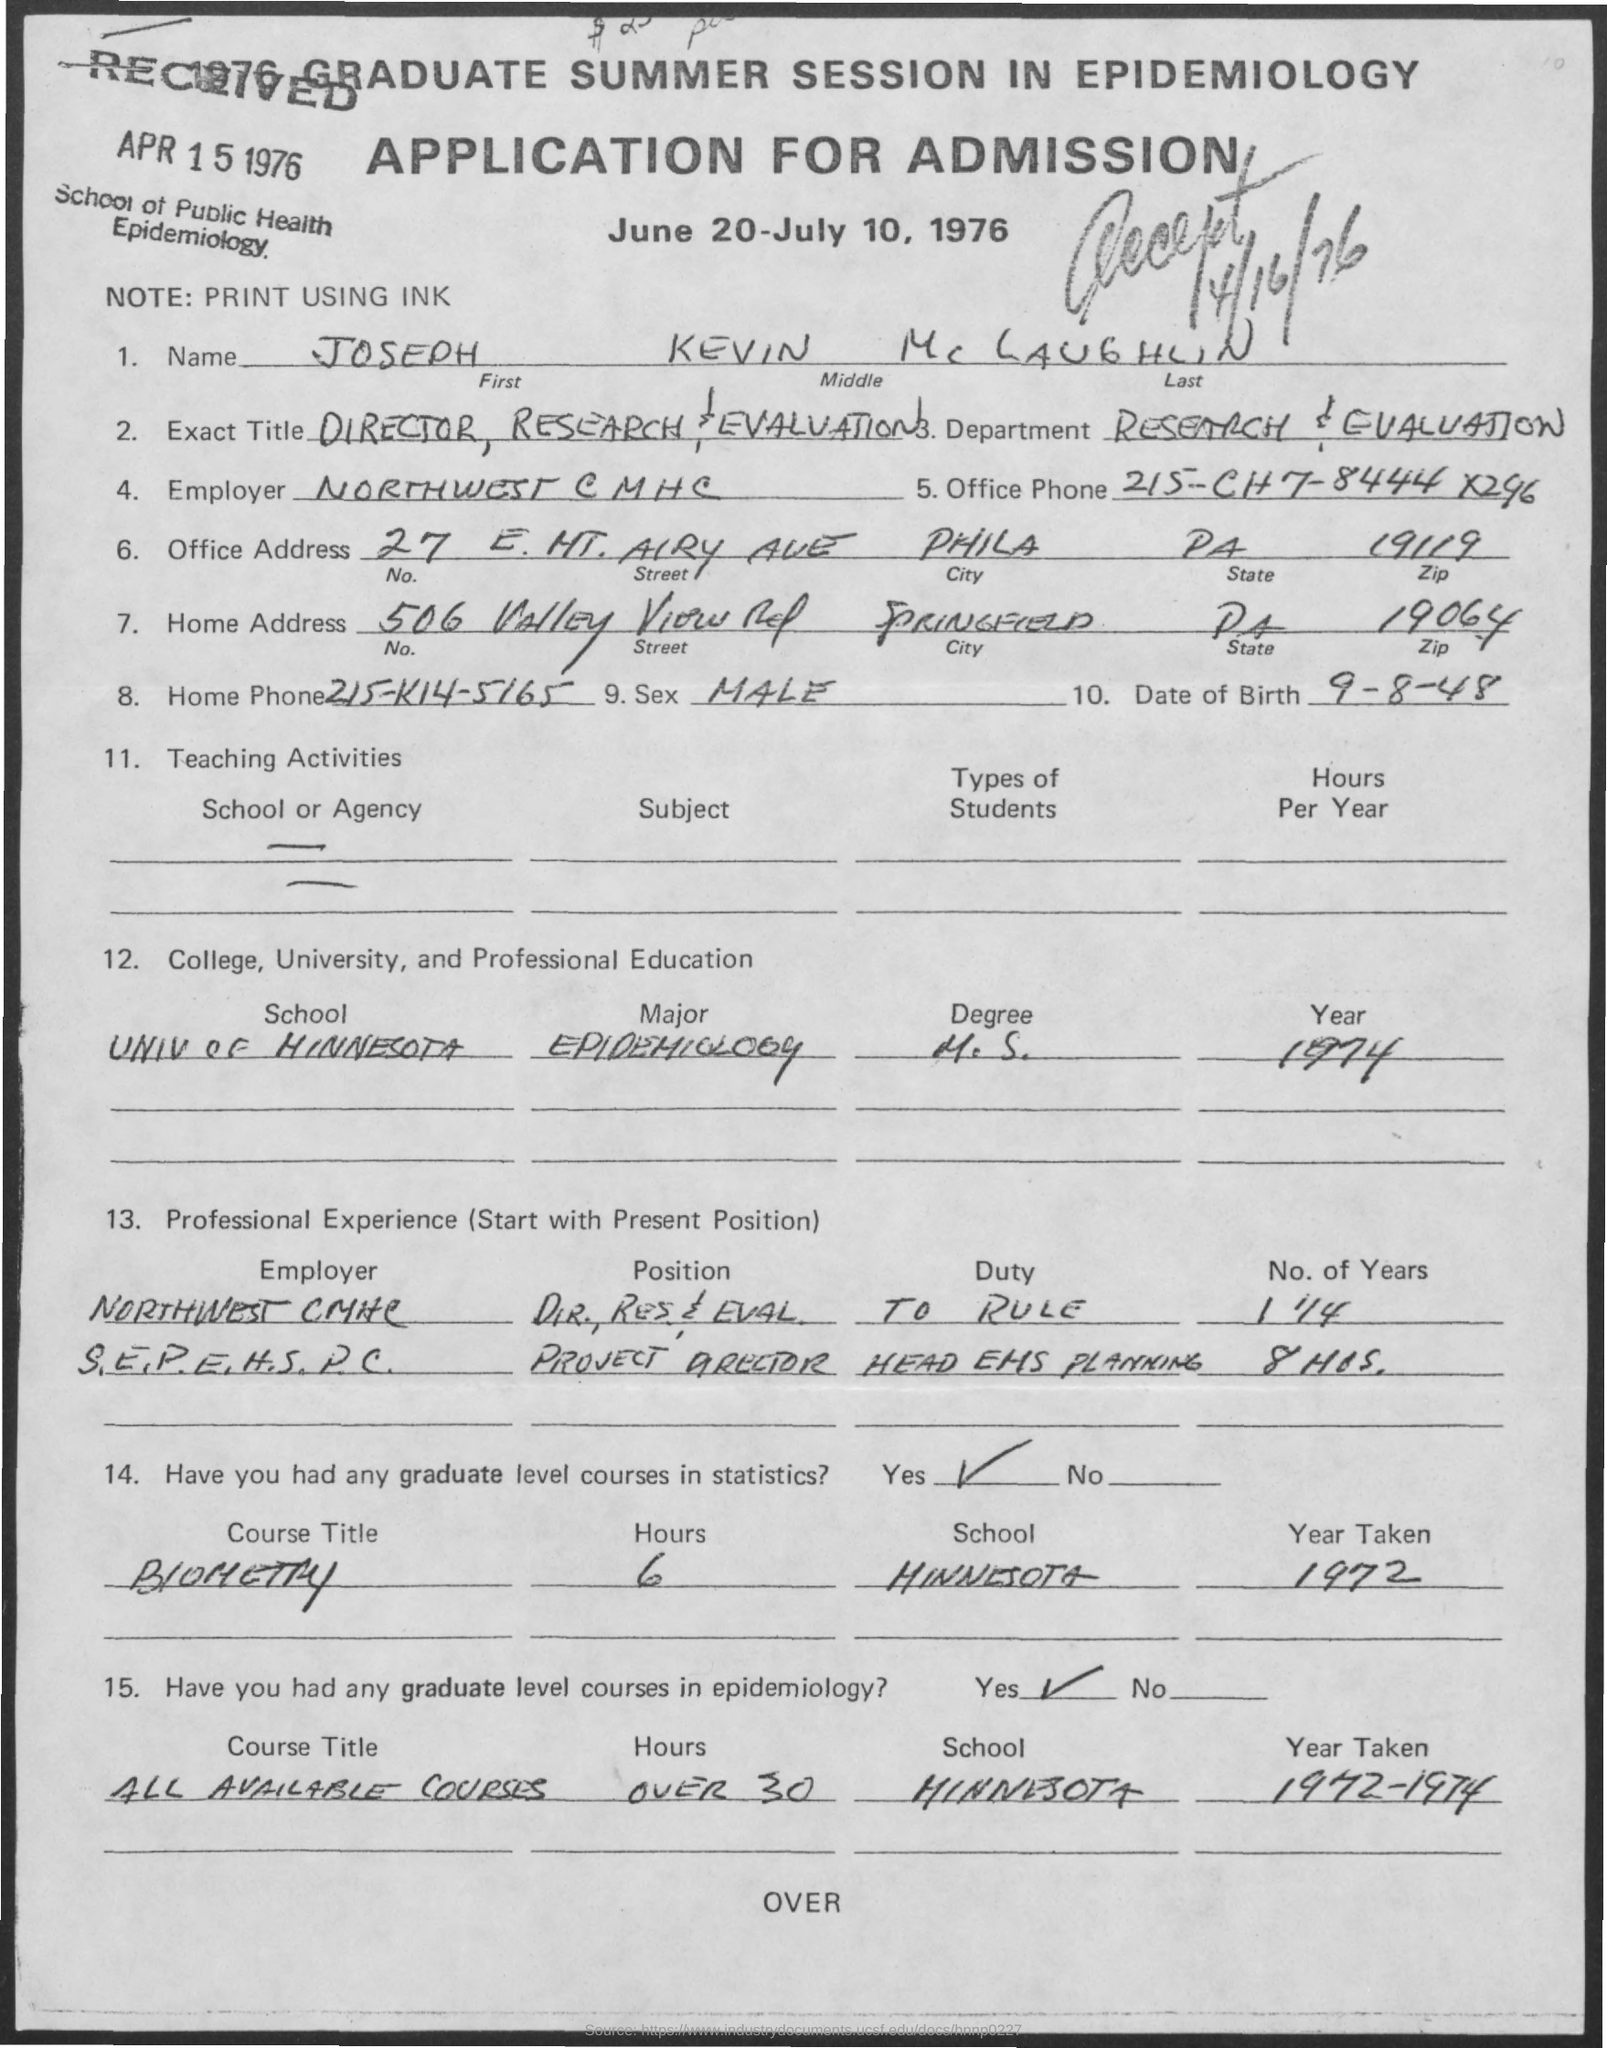What is the first name mentioned in the given application ?
Provide a short and direct response. Joseph. What is the middle name as mentioned in the given application ?
Keep it short and to the point. Kevin. What is the name of the department mentioned in the given application ?
Offer a very short reply. Research & evaluation. What is the exact title mentioned in the given application ?
Offer a very short reply. Director research & evaluation. What is the zip number for office address  mentioned in the given application ?
Offer a very short reply. 19119. What is the zip number for home address  mentioned in the given application ?
Make the answer very short. 19064. What is the date of birth mentioned in the given application ?
Make the answer very short. 9-8-48. What is the sex mentioned in the given application ?
Your answer should be very brief. Male. On which date the application was received ?
Give a very brief answer. APR 15 1976. 